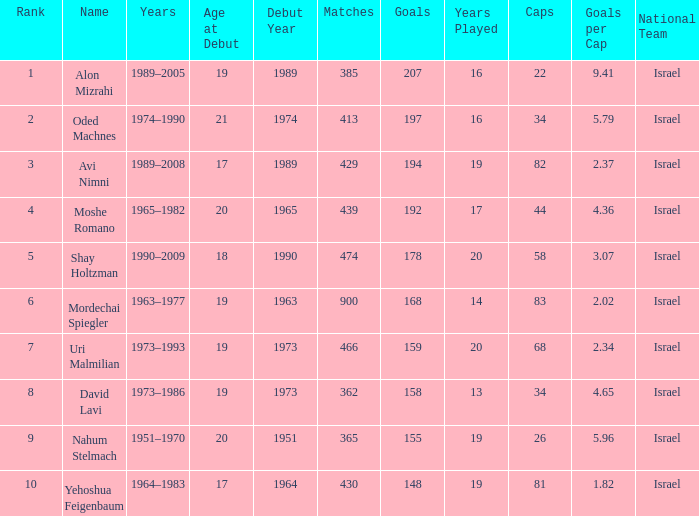What is the Rank of the player with 362 Matches? 8.0. 